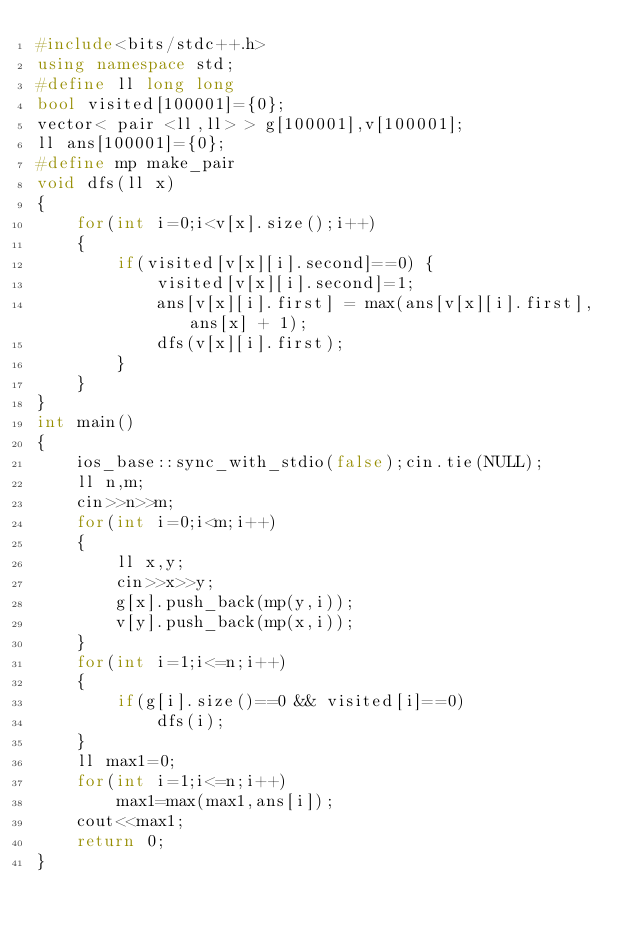<code> <loc_0><loc_0><loc_500><loc_500><_C++_>#include<bits/stdc++.h>
using namespace std;
#define ll long long
bool visited[100001]={0};
vector< pair <ll,ll> > g[100001],v[100001];
ll ans[100001]={0};
#define mp make_pair
void dfs(ll x)
{
    for(int i=0;i<v[x].size();i++)
    {
        if(visited[v[x][i].second]==0) {
            visited[v[x][i].second]=1;
            ans[v[x][i].first] = max(ans[v[x][i].first], ans[x] + 1);
            dfs(v[x][i].first);
        }
    }
}
int main()
{
    ios_base::sync_with_stdio(false);cin.tie(NULL);
    ll n,m;
    cin>>n>>m;
    for(int i=0;i<m;i++)
    {
        ll x,y;
        cin>>x>>y;
        g[x].push_back(mp(y,i));
        v[y].push_back(mp(x,i));
    }
    for(int i=1;i<=n;i++)
    {
        if(g[i].size()==0 && visited[i]==0)
            dfs(i);
    }
    ll max1=0;
    for(int i=1;i<=n;i++)
        max1=max(max1,ans[i]);
    cout<<max1;
    return 0;
}</code> 